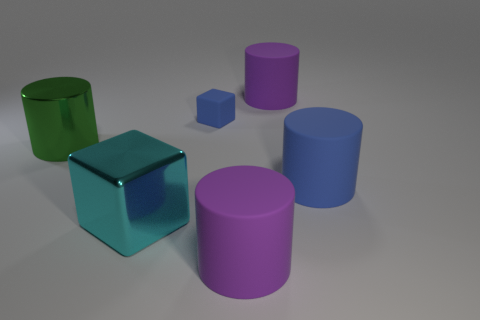Add 2 big blue matte objects. How many objects exist? 8 Subtract all cubes. How many objects are left? 4 Subtract 0 red cylinders. How many objects are left? 6 Subtract all blue matte cylinders. Subtract all red metal cubes. How many objects are left? 5 Add 2 big purple cylinders. How many big purple cylinders are left? 4 Add 5 big things. How many big things exist? 10 